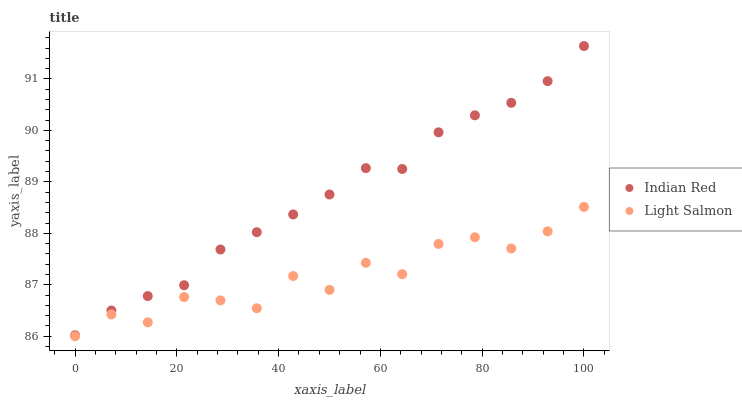Does Light Salmon have the minimum area under the curve?
Answer yes or no. Yes. Does Indian Red have the maximum area under the curve?
Answer yes or no. Yes. Does Indian Red have the minimum area under the curve?
Answer yes or no. No. Is Indian Red the smoothest?
Answer yes or no. Yes. Is Light Salmon the roughest?
Answer yes or no. Yes. Is Indian Red the roughest?
Answer yes or no. No. Does Light Salmon have the lowest value?
Answer yes or no. Yes. Does Indian Red have the lowest value?
Answer yes or no. No. Does Indian Red have the highest value?
Answer yes or no. Yes. Is Light Salmon less than Indian Red?
Answer yes or no. Yes. Is Indian Red greater than Light Salmon?
Answer yes or no. Yes. Does Light Salmon intersect Indian Red?
Answer yes or no. No. 